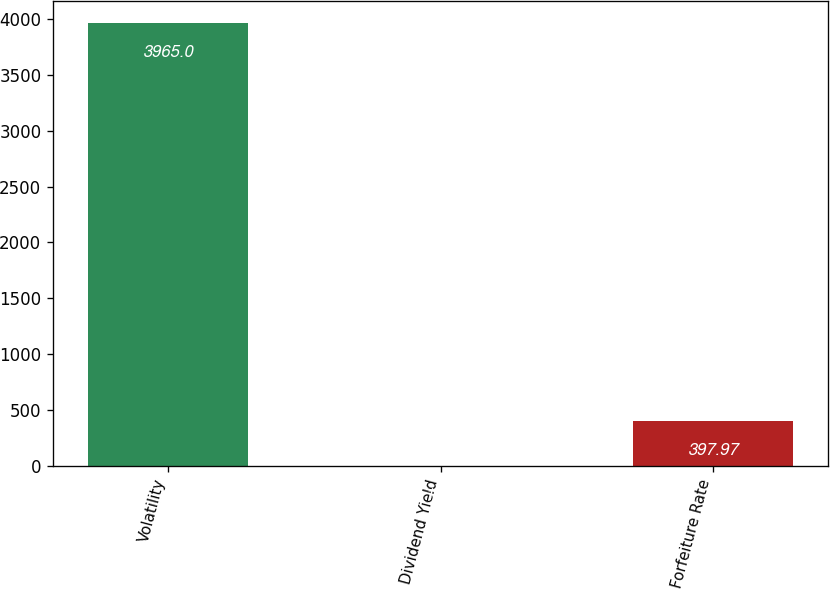<chart> <loc_0><loc_0><loc_500><loc_500><bar_chart><fcel>Volatility<fcel>Dividend Yield<fcel>Forfeiture Rate<nl><fcel>3965<fcel>1.63<fcel>397.97<nl></chart> 